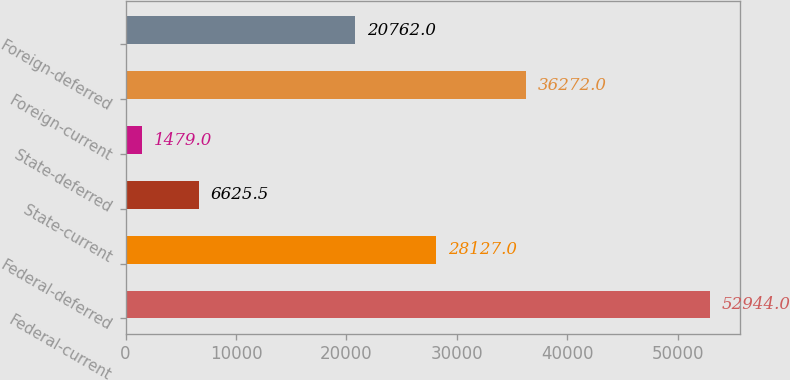<chart> <loc_0><loc_0><loc_500><loc_500><bar_chart><fcel>Federal-current<fcel>Federal-deferred<fcel>State-current<fcel>State-deferred<fcel>Foreign-current<fcel>Foreign-deferred<nl><fcel>52944<fcel>28127<fcel>6625.5<fcel>1479<fcel>36272<fcel>20762<nl></chart> 